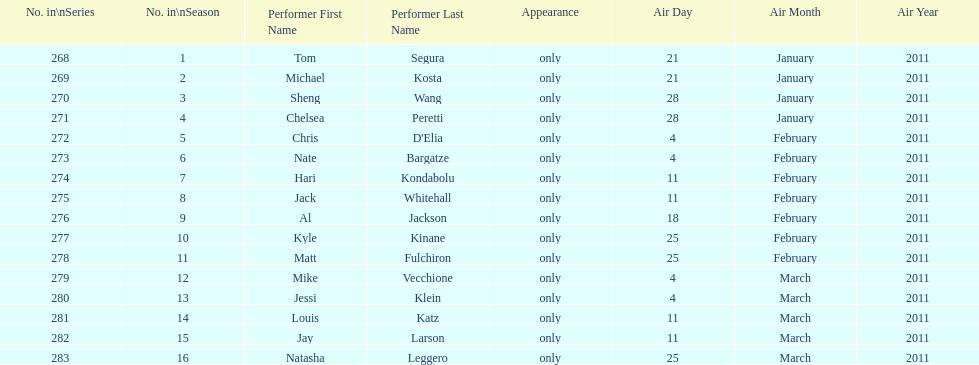What was hari's last name? Kondabolu. 